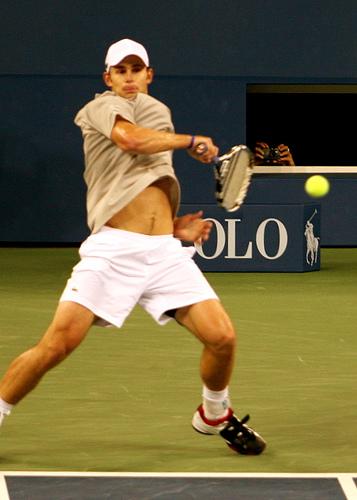What is the name of the tennis player?
Short answer required. George. What color are the man's shoes?
Write a very short answer. Black. Is the man playing volleyball?
Write a very short answer. No. What company is a sponsor of this event?
Answer briefly. Polo. 